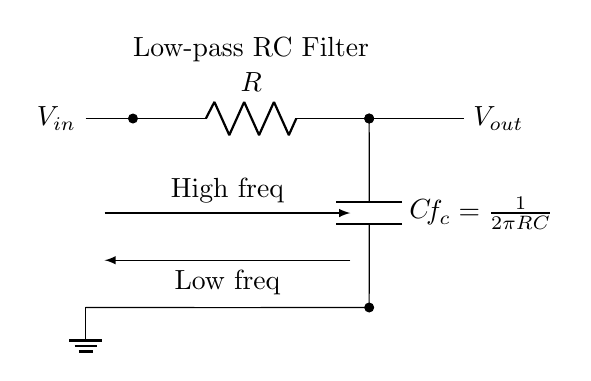What are the two main components of this RC low-pass filter? The main components are a resistor and a capacitor. These components are shown in the circuit diagram, with the resistor labeled as R and the capacitor labeled as C.
Answer: Resistor and capacitor What is the function of the RC low-pass filter in this circuit? The function of the RC low-pass filter is to allow low-frequency signals to pass while attenuating high-frequency signals. This is indicated by the arrows in the schematic showing the direction of signal flow.
Answer: Noise reduction What is the formula for the cutoff frequency of this filter? The cutoff frequency is derived from the relationship between resistance and capacitance in the formula provided in the diagram, which is frequency equal to one divided by two pi times R times C.
Answer: f_c = 1/(2πRC) What happens to high-frequency signals at the output of this filter? High-frequency signals are attenuated as they pass through the RC filter, leading to a reduced amplitude at the output. This behavior is visually represented by the directional arrows indicating signal flow from input to output.
Answer: Attenuated What does the ground symbol indicate in this circuit? The ground symbol signifies the reference point in the circuit where voltages are measured and serves as the return path for current. This connection is visually shown at the bottom of the capacitor and ensures the circuit is correctly referenced.
Answer: Reference point How does increasing the resistor value affect the cutoff frequency? Increasing the resistor value results in a lower cutoff frequency, as per the formula f_c = 1/(2πRC), meaning that the circuit will allow fewer high-frequency signals through. This relationship illustrates the inverse proportionality of frequency to resistance in the circuit.
Answer: Lower cutoff frequency 